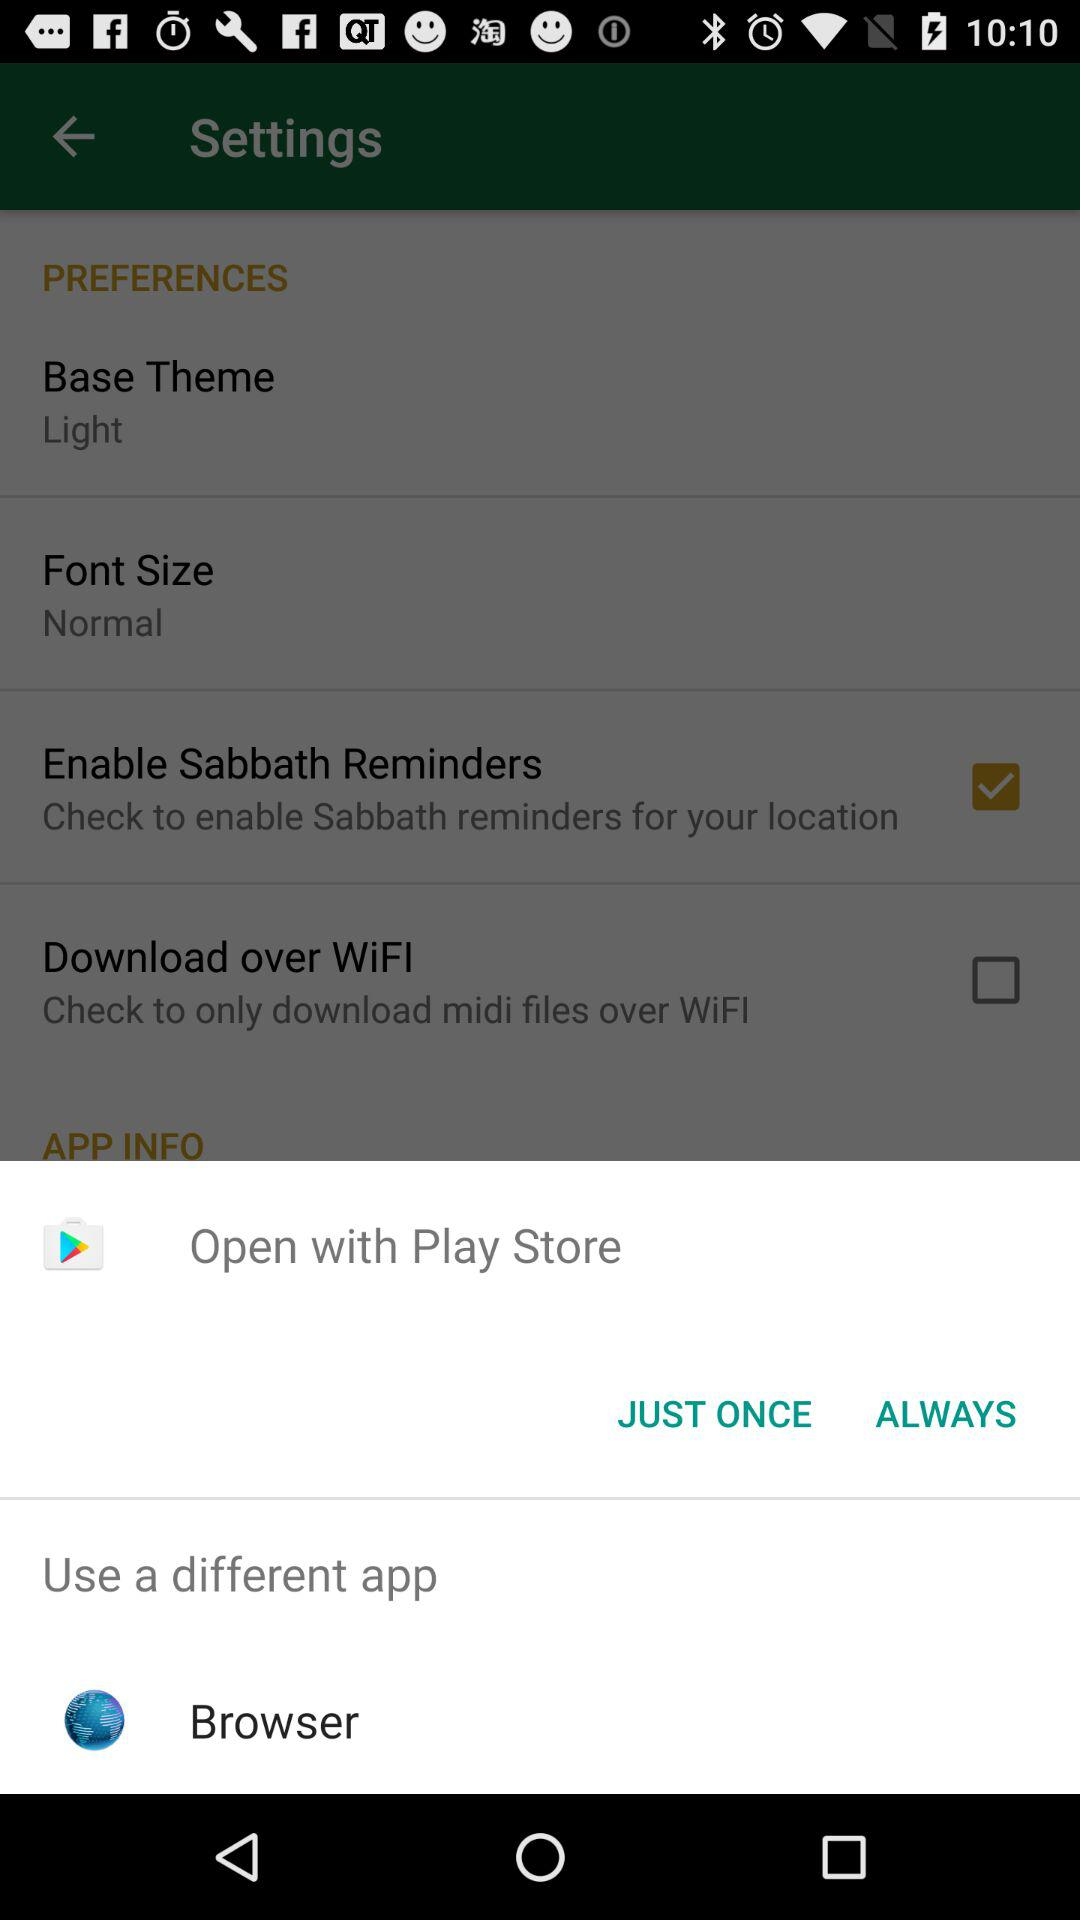What are the options to open with? The options are "Play Store" and "Browser". 